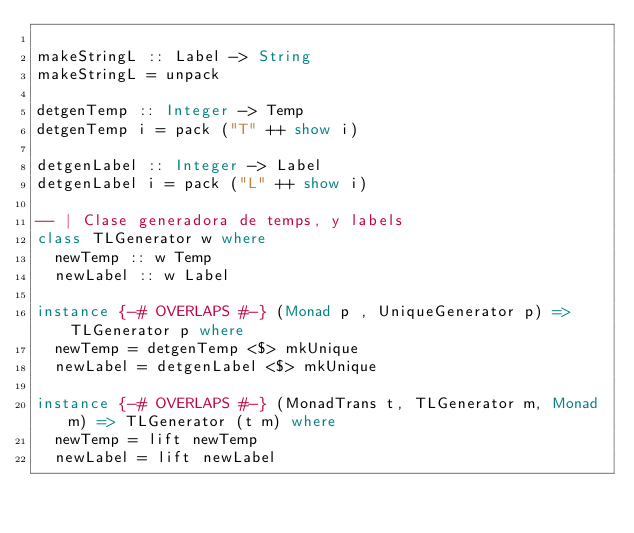<code> <loc_0><loc_0><loc_500><loc_500><_Haskell_>
makeStringL :: Label -> String
makeStringL = unpack

detgenTemp :: Integer -> Temp
detgenTemp i = pack ("T" ++ show i)

detgenLabel :: Integer -> Label
detgenLabel i = pack ("L" ++ show i)

-- | Clase generadora de temps, y labels
class TLGenerator w where
  newTemp :: w Temp
  newLabel :: w Label

instance {-# OVERLAPS #-} (Monad p , UniqueGenerator p) => TLGenerator p where
  newTemp = detgenTemp <$> mkUnique
  newLabel = detgenLabel <$> mkUnique

instance {-# OVERLAPS #-} (MonadTrans t, TLGenerator m, Monad m) => TLGenerator (t m) where
  newTemp = lift newTemp
  newLabel = lift newLabel
</code> 